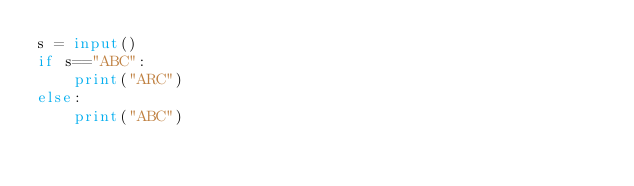<code> <loc_0><loc_0><loc_500><loc_500><_Python_>s = input()
if s=="ABC":
    print("ARC")
else:
    print("ABC")</code> 